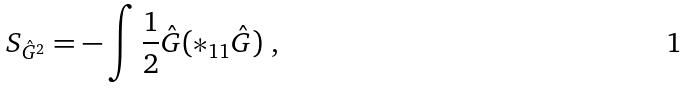<formula> <loc_0><loc_0><loc_500><loc_500>S _ { \hat { G } ^ { 2 } } = - \int \frac { 1 } { 2 } \hat { G } ( \ast _ { 1 1 } \hat { G } ) \ ,</formula> 